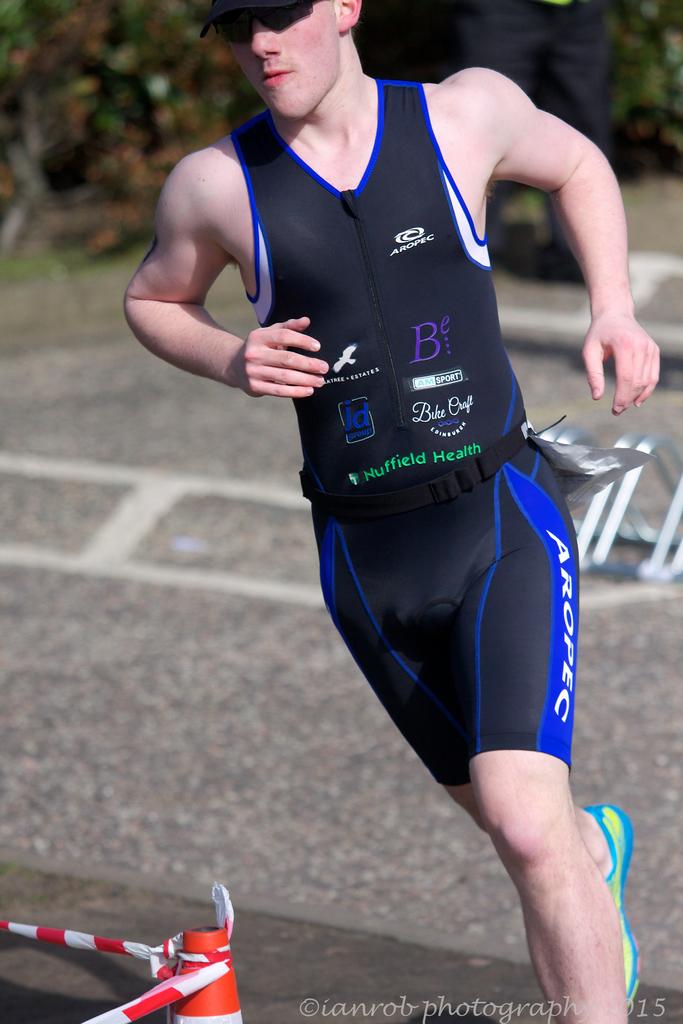What's one of his sponsors?
Keep it short and to the point. Nuffield health. What word is written across his shorts?
Give a very brief answer. Aropec. 